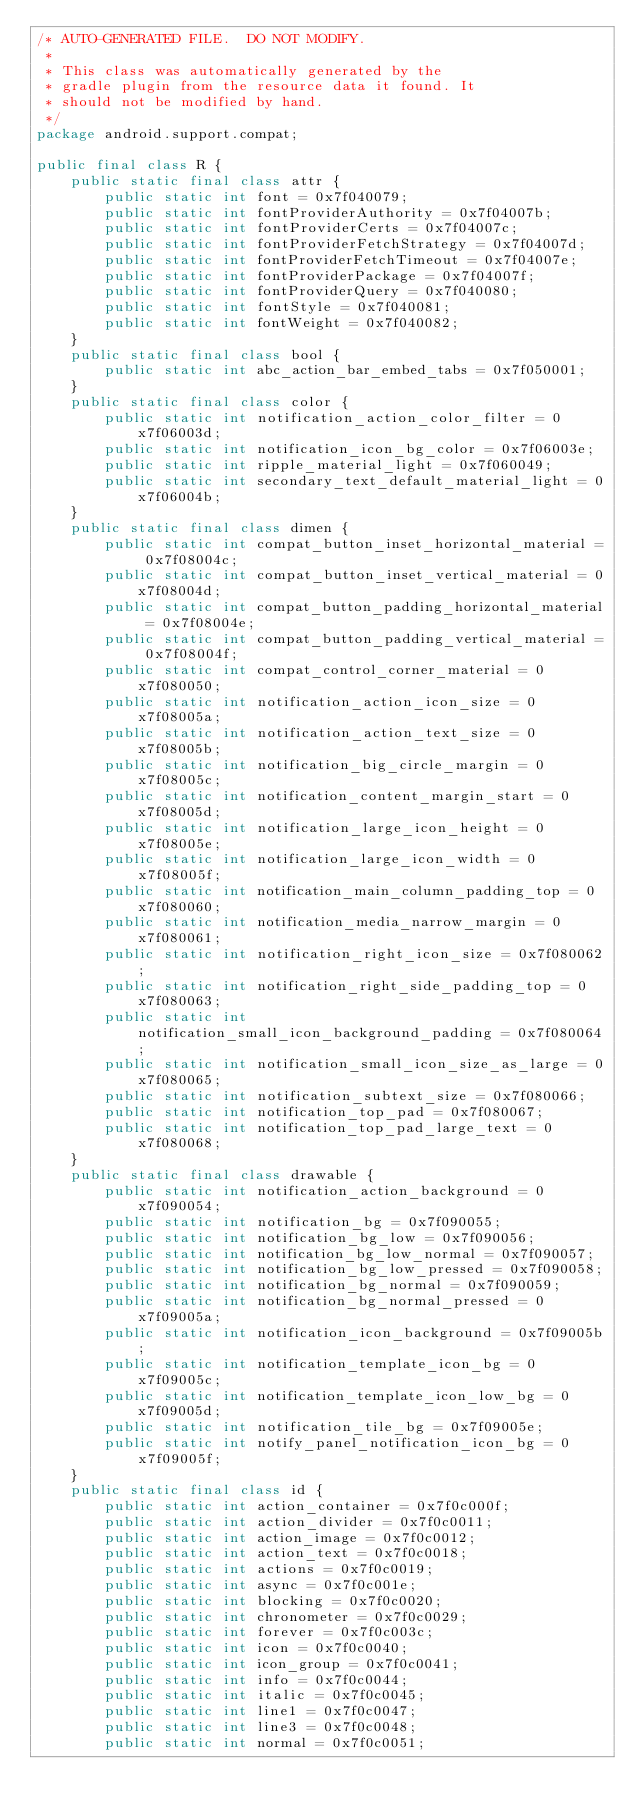<code> <loc_0><loc_0><loc_500><loc_500><_Java_>/* AUTO-GENERATED FILE.  DO NOT MODIFY.
 *
 * This class was automatically generated by the
 * gradle plugin from the resource data it found. It
 * should not be modified by hand.
 */
package android.support.compat;

public final class R {
    public static final class attr {
        public static int font = 0x7f040079;
        public static int fontProviderAuthority = 0x7f04007b;
        public static int fontProviderCerts = 0x7f04007c;
        public static int fontProviderFetchStrategy = 0x7f04007d;
        public static int fontProviderFetchTimeout = 0x7f04007e;
        public static int fontProviderPackage = 0x7f04007f;
        public static int fontProviderQuery = 0x7f040080;
        public static int fontStyle = 0x7f040081;
        public static int fontWeight = 0x7f040082;
    }
    public static final class bool {
        public static int abc_action_bar_embed_tabs = 0x7f050001;
    }
    public static final class color {
        public static int notification_action_color_filter = 0x7f06003d;
        public static int notification_icon_bg_color = 0x7f06003e;
        public static int ripple_material_light = 0x7f060049;
        public static int secondary_text_default_material_light = 0x7f06004b;
    }
    public static final class dimen {
        public static int compat_button_inset_horizontal_material = 0x7f08004c;
        public static int compat_button_inset_vertical_material = 0x7f08004d;
        public static int compat_button_padding_horizontal_material = 0x7f08004e;
        public static int compat_button_padding_vertical_material = 0x7f08004f;
        public static int compat_control_corner_material = 0x7f080050;
        public static int notification_action_icon_size = 0x7f08005a;
        public static int notification_action_text_size = 0x7f08005b;
        public static int notification_big_circle_margin = 0x7f08005c;
        public static int notification_content_margin_start = 0x7f08005d;
        public static int notification_large_icon_height = 0x7f08005e;
        public static int notification_large_icon_width = 0x7f08005f;
        public static int notification_main_column_padding_top = 0x7f080060;
        public static int notification_media_narrow_margin = 0x7f080061;
        public static int notification_right_icon_size = 0x7f080062;
        public static int notification_right_side_padding_top = 0x7f080063;
        public static int notification_small_icon_background_padding = 0x7f080064;
        public static int notification_small_icon_size_as_large = 0x7f080065;
        public static int notification_subtext_size = 0x7f080066;
        public static int notification_top_pad = 0x7f080067;
        public static int notification_top_pad_large_text = 0x7f080068;
    }
    public static final class drawable {
        public static int notification_action_background = 0x7f090054;
        public static int notification_bg = 0x7f090055;
        public static int notification_bg_low = 0x7f090056;
        public static int notification_bg_low_normal = 0x7f090057;
        public static int notification_bg_low_pressed = 0x7f090058;
        public static int notification_bg_normal = 0x7f090059;
        public static int notification_bg_normal_pressed = 0x7f09005a;
        public static int notification_icon_background = 0x7f09005b;
        public static int notification_template_icon_bg = 0x7f09005c;
        public static int notification_template_icon_low_bg = 0x7f09005d;
        public static int notification_tile_bg = 0x7f09005e;
        public static int notify_panel_notification_icon_bg = 0x7f09005f;
    }
    public static final class id {
        public static int action_container = 0x7f0c000f;
        public static int action_divider = 0x7f0c0011;
        public static int action_image = 0x7f0c0012;
        public static int action_text = 0x7f0c0018;
        public static int actions = 0x7f0c0019;
        public static int async = 0x7f0c001e;
        public static int blocking = 0x7f0c0020;
        public static int chronometer = 0x7f0c0029;
        public static int forever = 0x7f0c003c;
        public static int icon = 0x7f0c0040;
        public static int icon_group = 0x7f0c0041;
        public static int info = 0x7f0c0044;
        public static int italic = 0x7f0c0045;
        public static int line1 = 0x7f0c0047;
        public static int line3 = 0x7f0c0048;
        public static int normal = 0x7f0c0051;</code> 